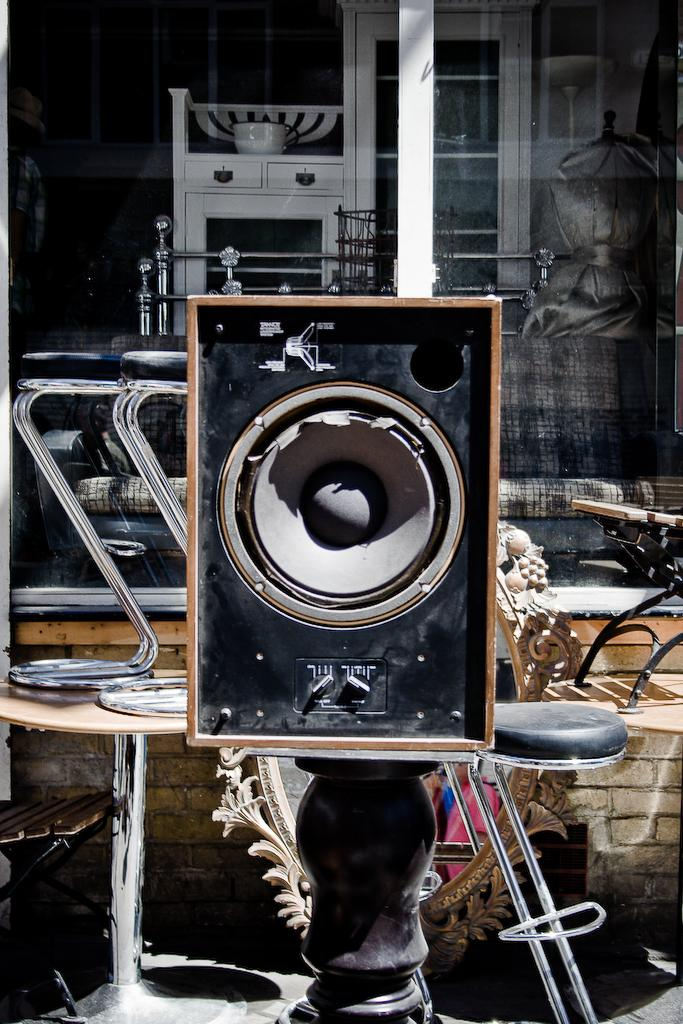What type of furniture is present in the image? There are tables in the image. What device can be seen in the image for amplifying sound? There is a speaker in the image. What type of transparent barrier is present in the image? There is a glass window in the image. What type of storage furniture is present in the image? There is a cupboard in the image. What reflective surface is present in the image? There is a mirror in the image. Can you describe any other objects present in the image? There are unspecified objects in the image. What type of drain is visible in the image? There is no drain present in the image. What season is depicted in the image? The image does not depict a specific season, so it cannot be determined from the image. 